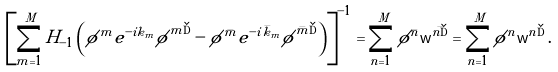Convert formula to latex. <formula><loc_0><loc_0><loc_500><loc_500>\left [ \sum _ { m = 1 } ^ { M } H _ { - 1 } \left ( { \phi } ^ { m } e ^ { - i k _ { m } } { \tilde { \phi } } ^ { m \dag } - { \phi } ^ { \bar { m } } e ^ { - i \bar { k } _ { m } } { \tilde { \phi } } ^ { \bar { m } \dag } \right ) \right ] ^ { - 1 } = \sum _ { n = 1 } ^ { M } { \phi } ^ { \bar { n } } { \mathsf w } ^ { \bar { n \dag } } = \sum _ { n = 1 } ^ { M } { \phi } ^ { n } { \mathsf w } ^ { n \dag } \, .</formula> 